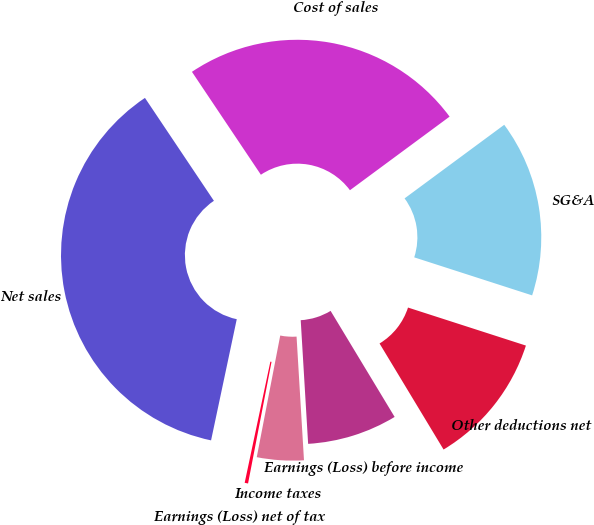Convert chart to OTSL. <chart><loc_0><loc_0><loc_500><loc_500><pie_chart><fcel>Net sales<fcel>Cost of sales<fcel>SG&A<fcel>Other deductions net<fcel>Earnings (Loss) before income<fcel>Income taxes<fcel>Earnings (Loss) net of tax<nl><fcel>37.28%<fcel>24.27%<fcel>15.09%<fcel>11.39%<fcel>7.69%<fcel>3.99%<fcel>0.29%<nl></chart> 